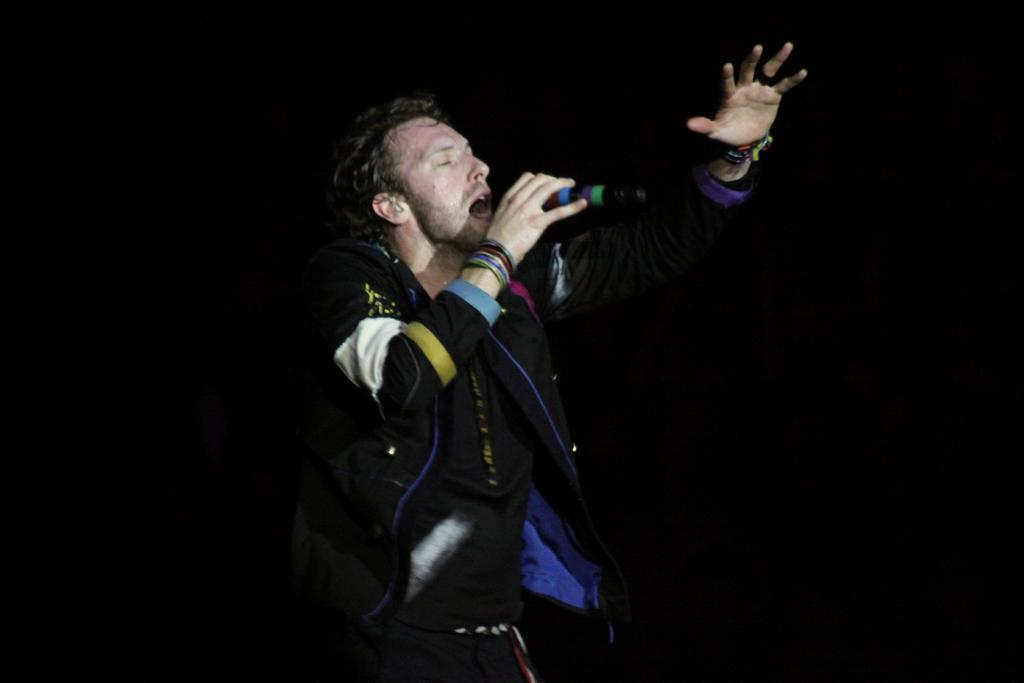What is the main subject of the image? The main subject of the image is a man. What is the man holding in the image? The man is holding a mic in the image. What is the man's posture in the image? The man is standing in the image. How many snakes can be seen slithering on the grass in the image? There are no snakes or grass present in the image. What is the man's temper like in the image? The provided facts do not give any information about the man's temper, so it cannot be determined from the image. 